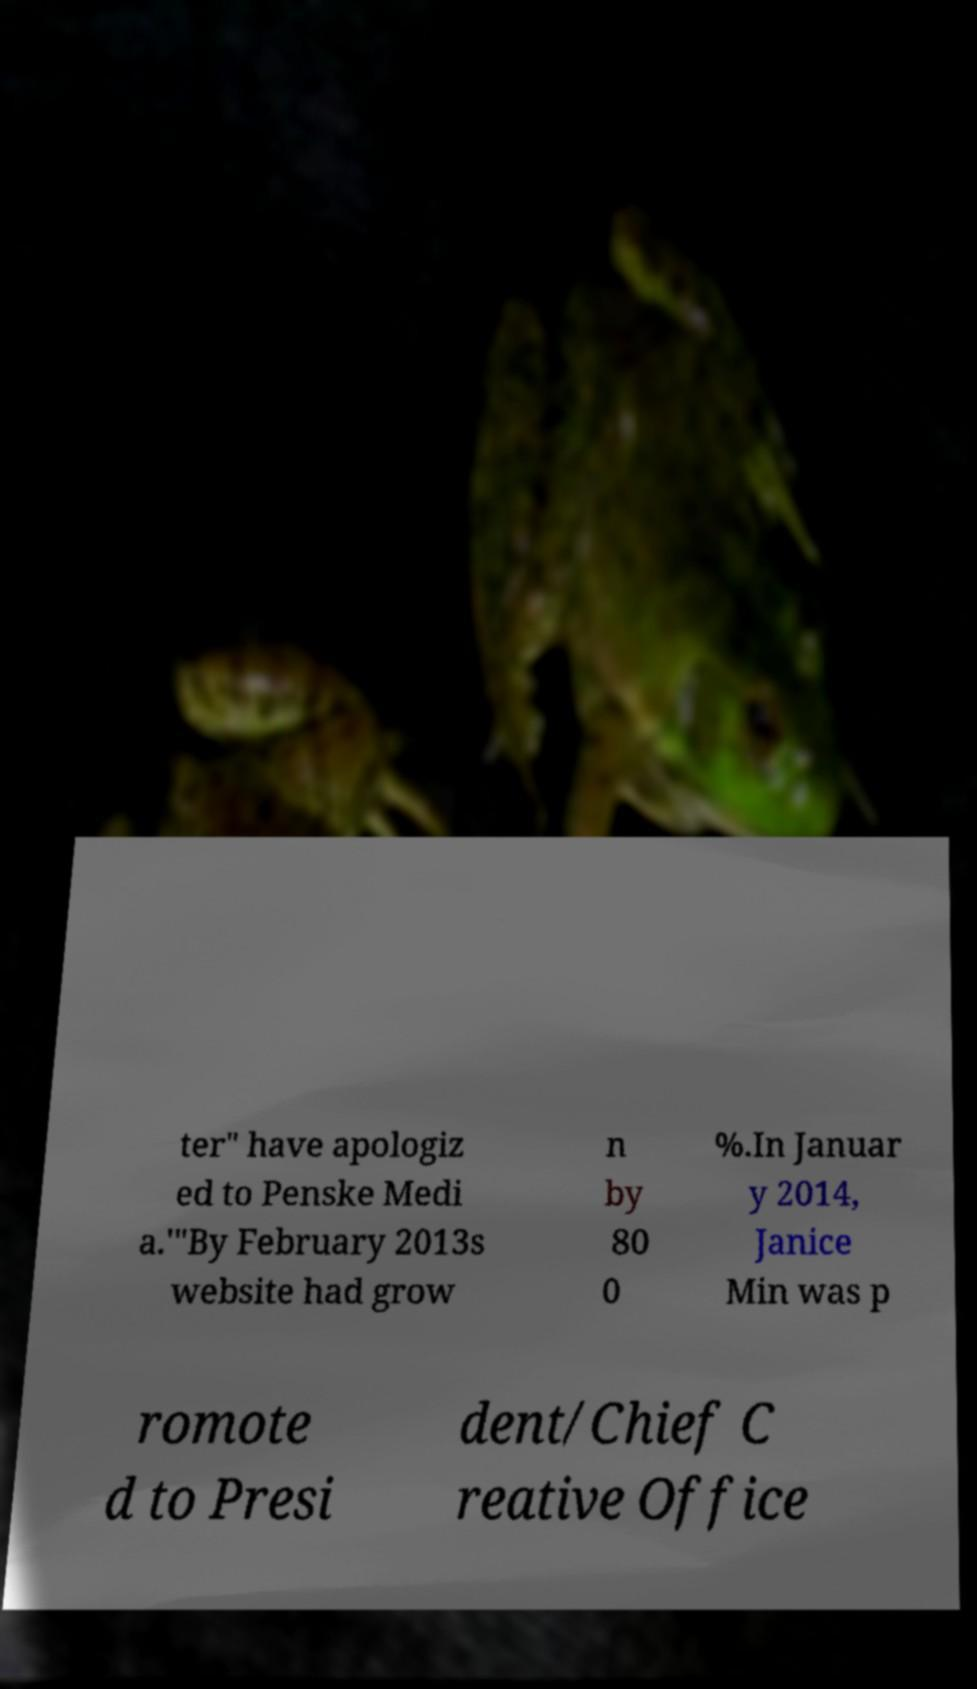Can you accurately transcribe the text from the provided image for me? ter" have apologiz ed to Penske Medi a.'"By February 2013s website had grow n by 80 0 %.In Januar y 2014, Janice Min was p romote d to Presi dent/Chief C reative Office 